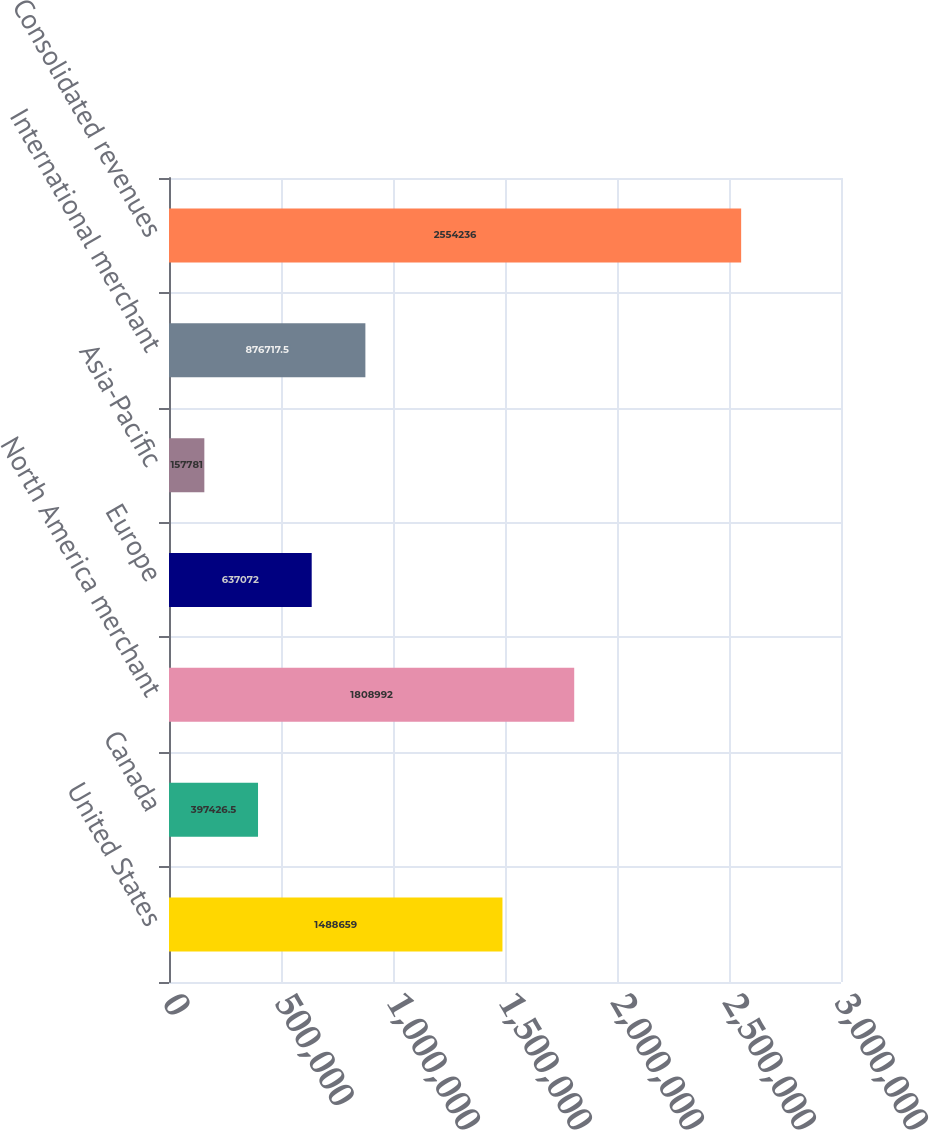<chart> <loc_0><loc_0><loc_500><loc_500><bar_chart><fcel>United States<fcel>Canada<fcel>North America merchant<fcel>Europe<fcel>Asia-Pacific<fcel>International merchant<fcel>Consolidated revenues<nl><fcel>1.48866e+06<fcel>397426<fcel>1.80899e+06<fcel>637072<fcel>157781<fcel>876718<fcel>2.55424e+06<nl></chart> 